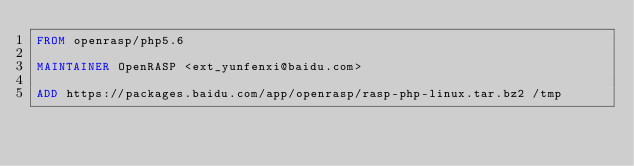<code> <loc_0><loc_0><loc_500><loc_500><_Dockerfile_>FROM openrasp/php5.6

MAINTAINER OpenRASP <ext_yunfenxi@baidu.com>

ADD https://packages.baidu.com/app/openrasp/rasp-php-linux.tar.bz2 /tmp</code> 